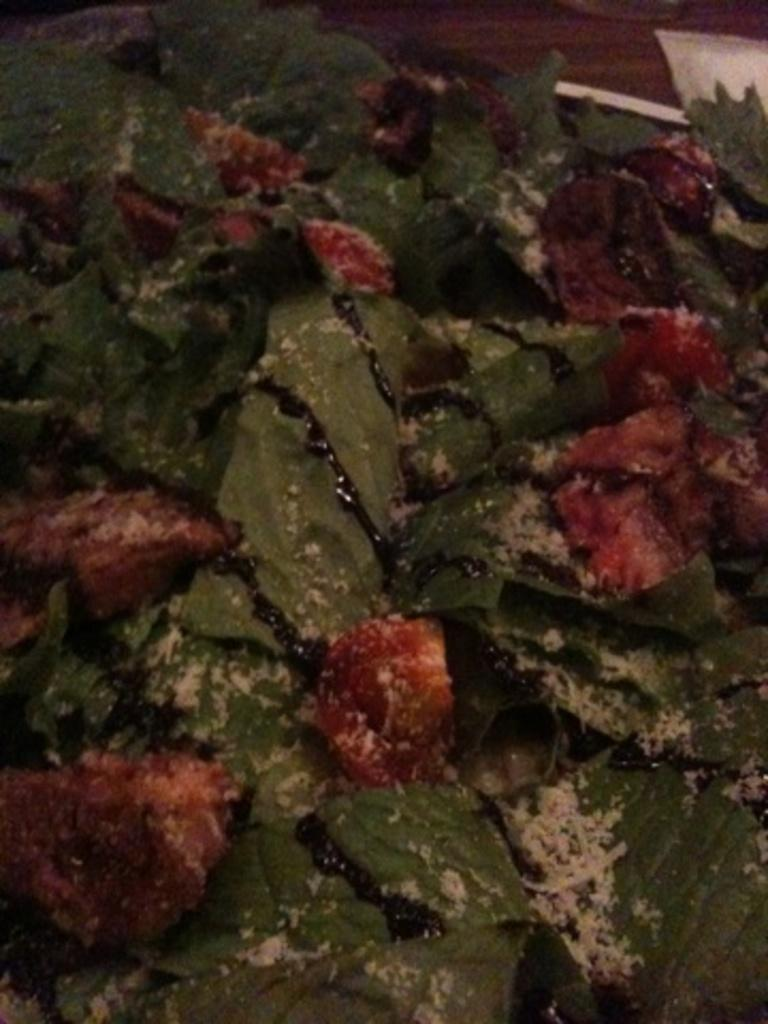What type of vegetation can be seen in the image? There are leaves in the image. What type of fruits are present in the image? There are red color fruits in the image. What type of copper material can be seen in the image? There is no copper material present in the image; it features leaves and red color fruits. Can you describe the hair of the friend in the image? There is no friend or hair present in the image. 